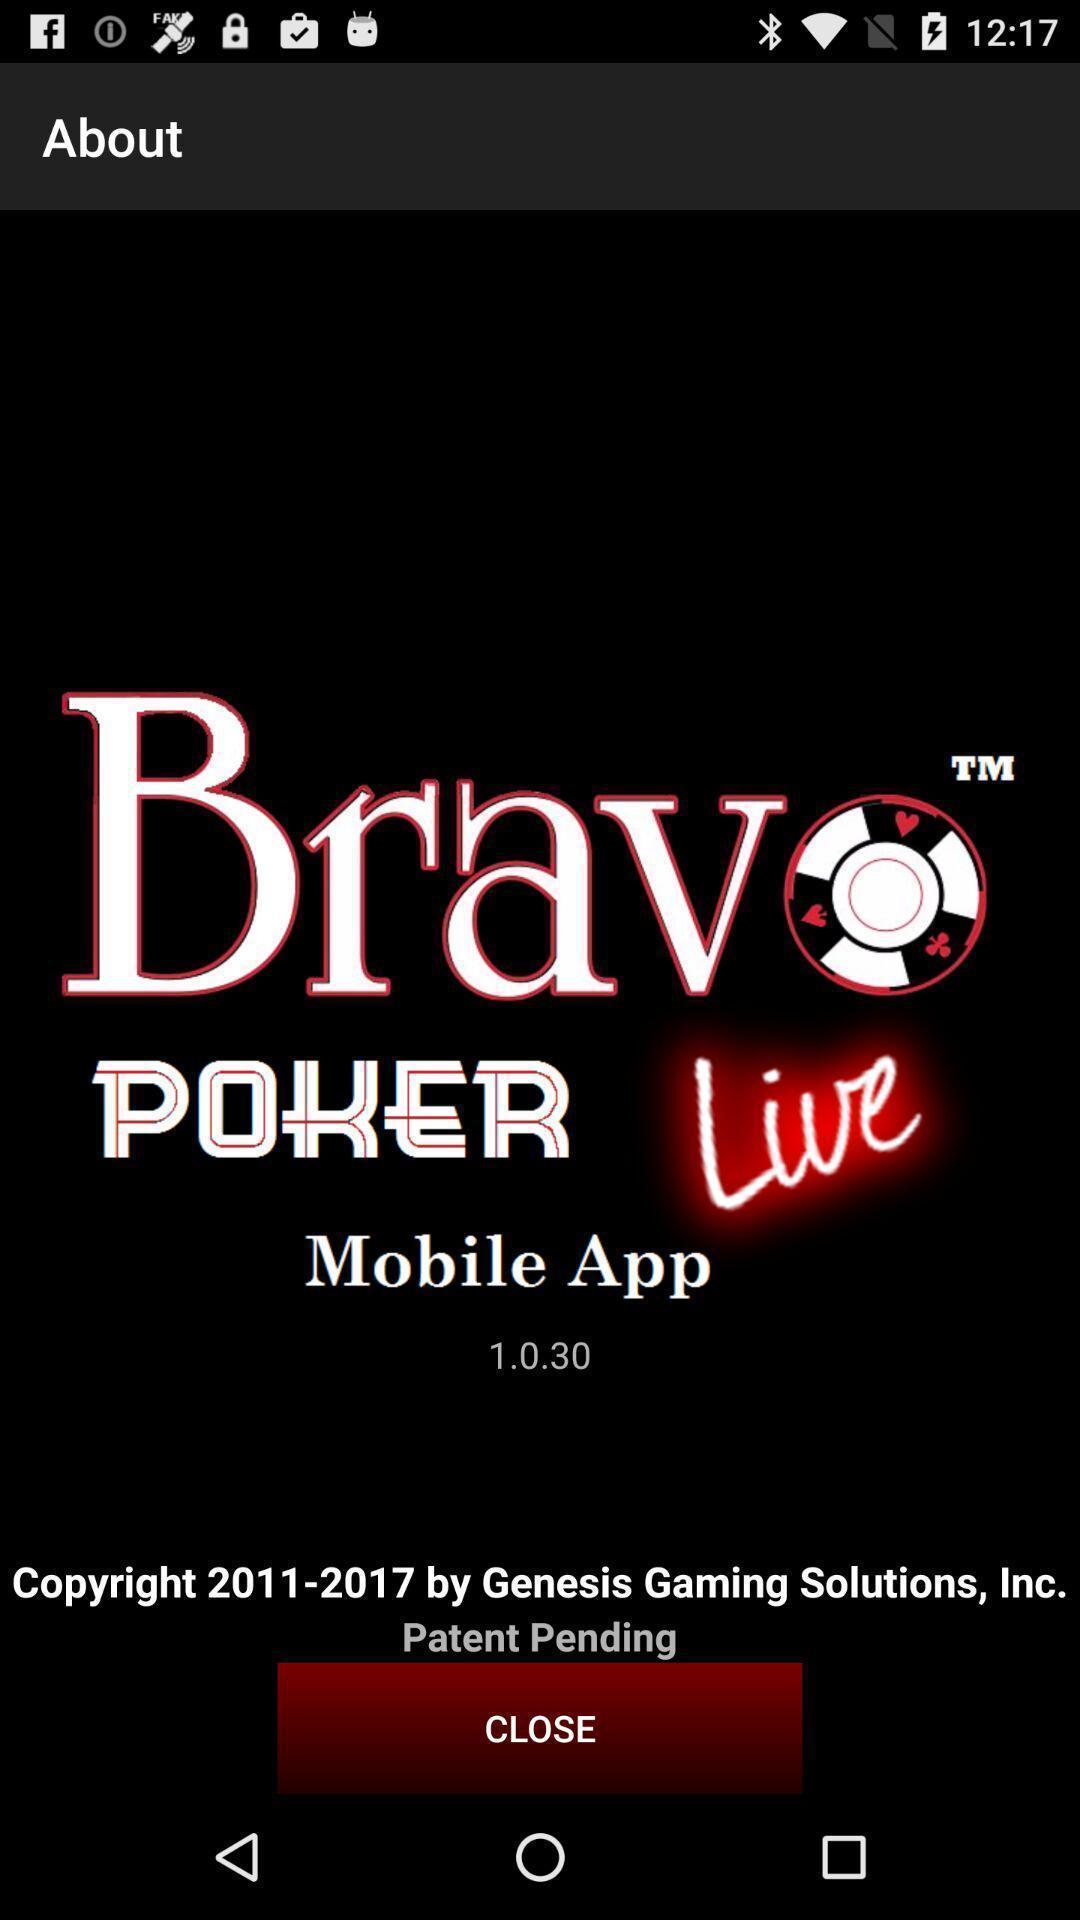Describe the key features of this screenshot. Screen displaying information about an application. 